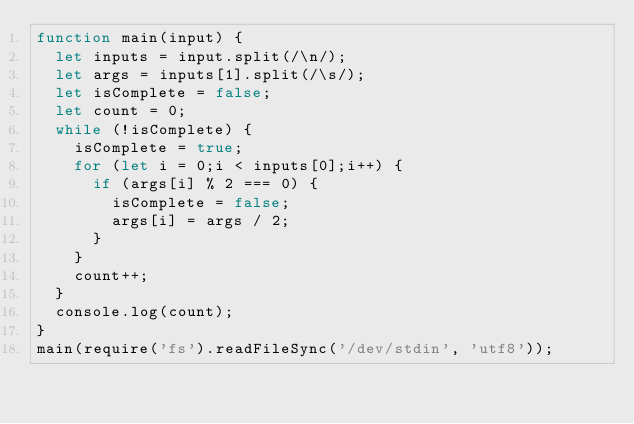<code> <loc_0><loc_0><loc_500><loc_500><_JavaScript_>function main(input) {
  let inputs = input.split(/\n/);
  let args = inputs[1].split(/\s/);
  let isComplete = false;
  let count = 0;
  while (!isComplete) {
    isComplete = true;
    for (let i = 0;i < inputs[0];i++) {
      if (args[i] % 2 === 0) {
        isComplete = false;
        args[i] = args / 2;
      }
    }
    count++;
  }
  console.log(count);
}
main(require('fs').readFileSync('/dev/stdin', 'utf8'));</code> 